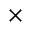Convert formula to latex. <formula><loc_0><loc_0><loc_500><loc_500>\times</formula> 